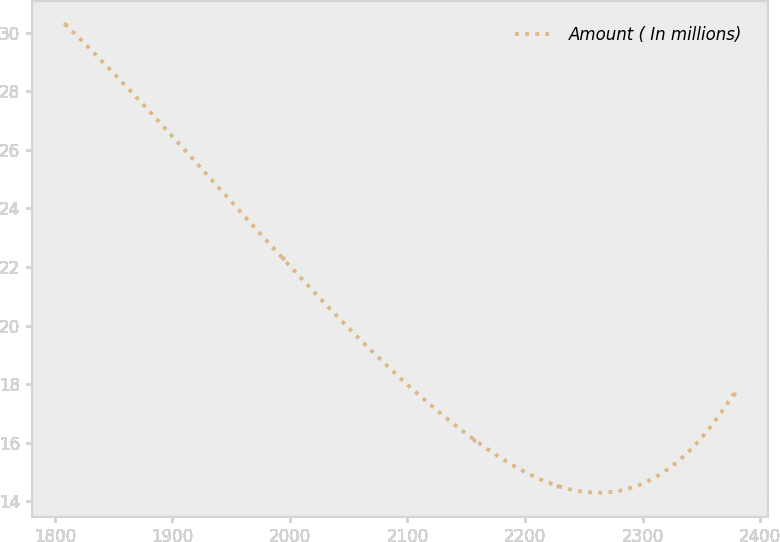Convert chart to OTSL. <chart><loc_0><loc_0><loc_500><loc_500><line_chart><ecel><fcel>Amount ( In millions)<nl><fcel>1808.72<fcel>30.29<nl><fcel>1993.76<fcel>22.3<nl><fcel>2157<fcel>16.1<nl><fcel>2228.47<fcel>14.52<nl><fcel>2377.45<fcel>17.68<nl></chart> 